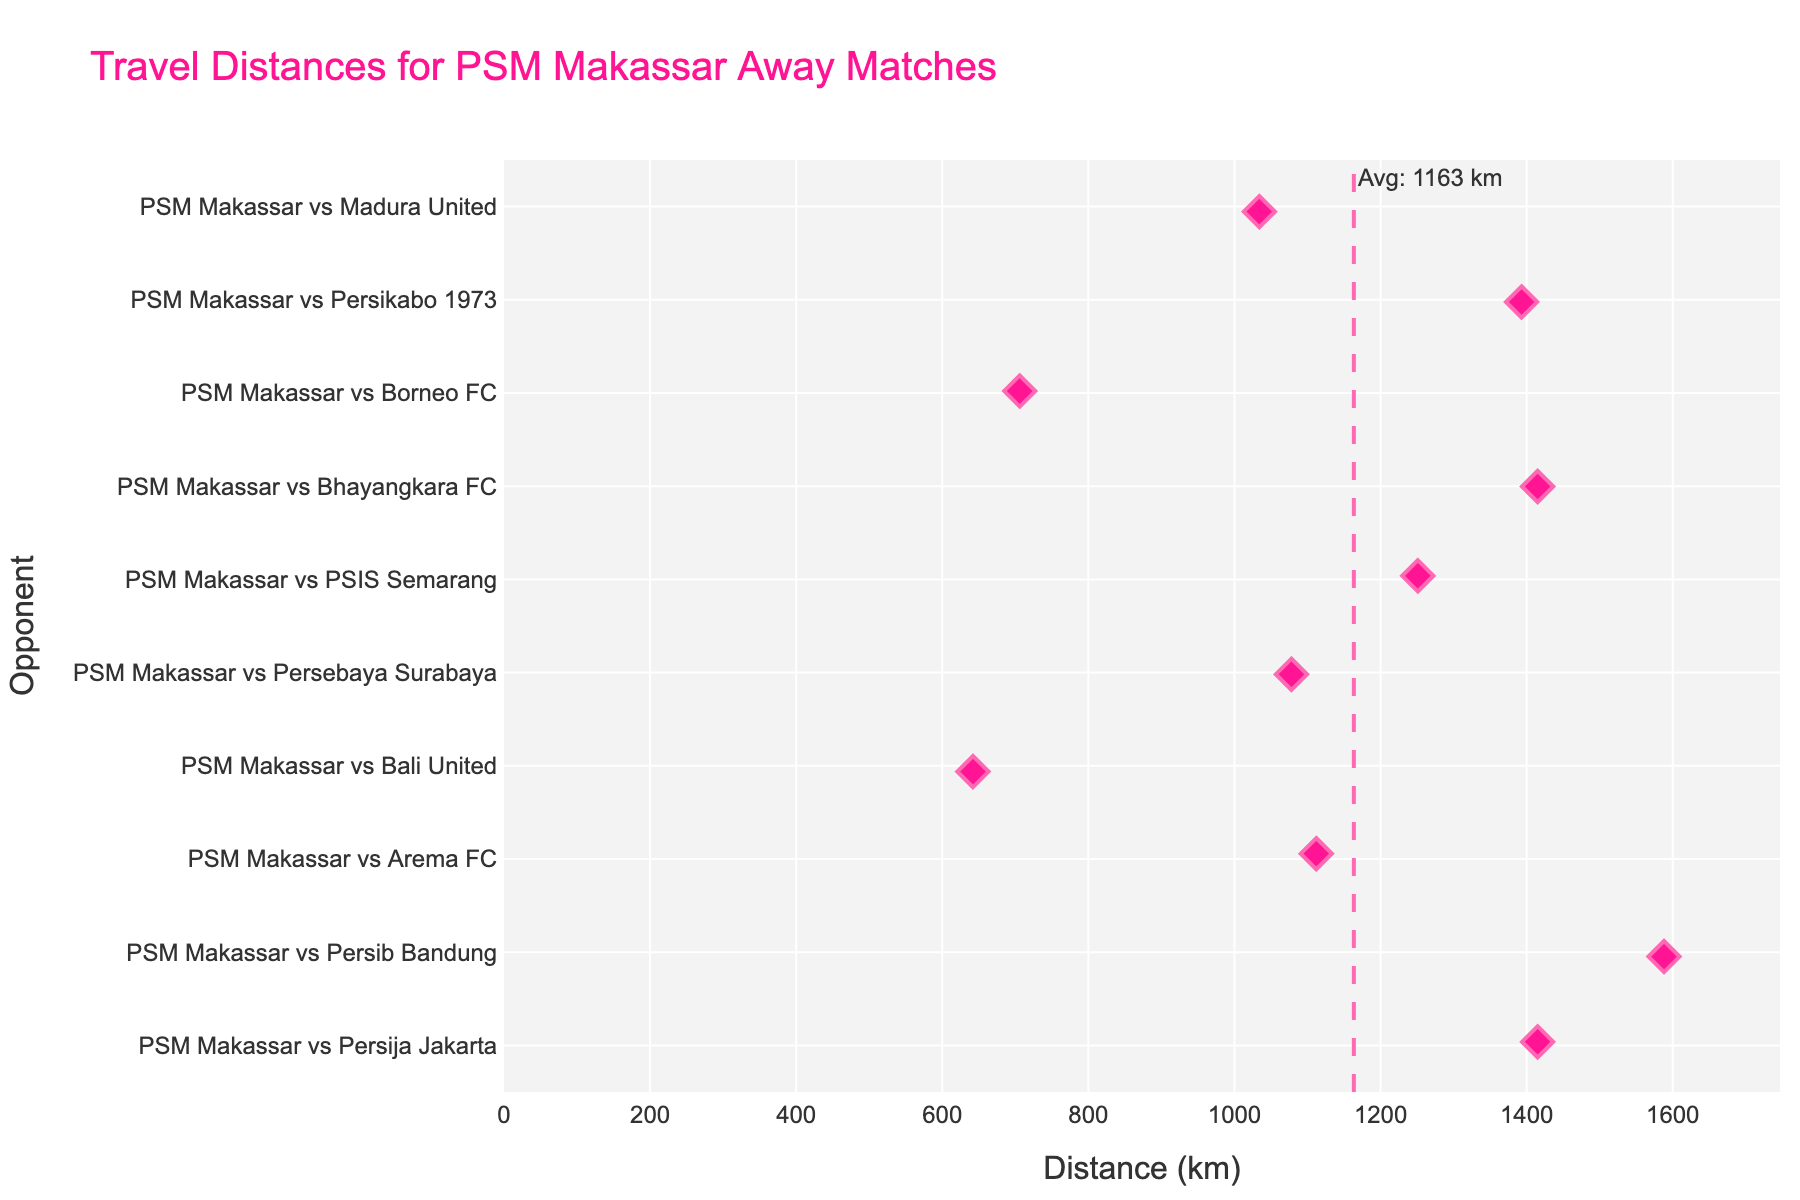What's the title of the figure? The title is usually displayed at the top of the figure. In this case, it is "Travel Distances for PSM Makassar Away Matches". This can be visually confirmed by looking at the top of the plot.
Answer: Travel Distances for PSM Makassar Away Matches Which match has the shortest travel distance? By looking at the horizontal axis, find the data point closest to zero. The match with the shortest travel distance corresponds to PSM Makassar vs Bali United, at 642 km.
Answer: PSM Makassar vs Bali United How many matches have a travel distance greater than 1,000 km? Count the number of data points to the right of the 1,000 km mark on the horizontal axis. These are Persija Jakarta, Persib Bandung, Arema FC, Persebaya Surabaya, PSIS Semarang, Bhayangkara FC, Persikabo 1973, and Madura United. This totals to 8 matches.
Answer: 8 Which match has the greatest travel distance? To find the match with the greatest travel distance, look for the data point farthest to the right on the horizontal axis. It corresponds to PSM Makassar vs Persib Bandung, with a distance of 1,588 km.
Answer: PSM Makassar vs Persib Bandung What is the average travel distance for PSM Makassar away matches? The average distance is indicated by the vertical line and annotated with "Avg: 1163 km". This was calculated by taking the mean of all the distances provided in the dataset.
Answer: 1163 km Which matches have a travel distance close to the average distance? Identify data points that are close to the vertical line marking the average distance. From visual inspection, the points closest to the average (1163 km) are PSM Makassar vs Arema FC (1112 km) and PSM Makassar vs Persebaya Surabaya (1078 km).
Answer: PSM Makassar vs Arema FC, PSM Makassar vs Persebaya Surabaya How many kilometers apart are the shortest and longest travel distances? Subtract the shortest distance (642 km) from the longest distance (1588 km) to find the difference. 1588 km - 642 km equals 946 km.
Answer: 946 km What is the color of the markers used in the strip plot? The color of the markers can be identified as pink, which is a distinctive color used in the plot as per the description provided.
Answer: Pink How many matches have a travel distance between 1,000 km and 1,500 km? Count the data points that fall between the 1,000 km and 1,500 km marks on the horizontal axis. Matches with distances in this range are Arema FC, Persebaya Surabaya, PSIS Semarang, Persija Jakarta, Bhayangkara FC, and Persikabo 1973. This totals to 6 matches.
Answer: 6 Which match is closest in travel distance to PSM Makassar vs Persikabo 1973? By observing that PSM Makassar vs Persikabo 1973 has a travel distance of 1393 km, we need to look for matches with travel distances nearby. The matches closest in distance are PSM Makassar vs Persija Jakarta and PSM Makassar vs Bhayangkara FC, both at 1415 km.
Answer: PSM Makassar vs Persija Jakarta, PSM Makassar vs Bhayangkara FC 